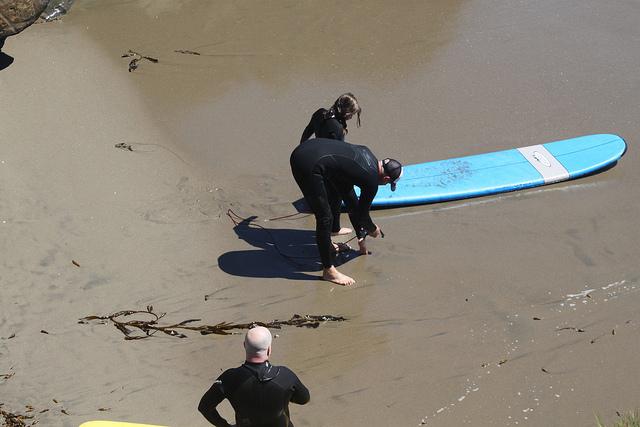What is he doing?
Write a very short answer. Surfing. What is the weather?
Answer briefly. Sunny. What color is the surfboard?
Quick response, please. Blue. What color is the pug wearing?
Concise answer only. Black. Is that a cartoon character?
Be succinct. No. Is the man jumping?
Give a very brief answer. No. Is it day out?
Write a very short answer. Yes. Is there snow?
Be succinct. No. Is the picture clear?
Concise answer only. Yes. What activity is this?
Quick response, please. Surfing. Are the surfers good?
Give a very brief answer. Yes. What is the guy doing?
Be succinct. Standing. Are the people wearing shoes?
Write a very short answer. No. What is attached to this person's feet?
Short answer required. Surfboard. What time of day is it?
Short answer required. Morning. Is the man excited?
Be succinct. No. Is the man doing a trick?
Quick response, please. No. 